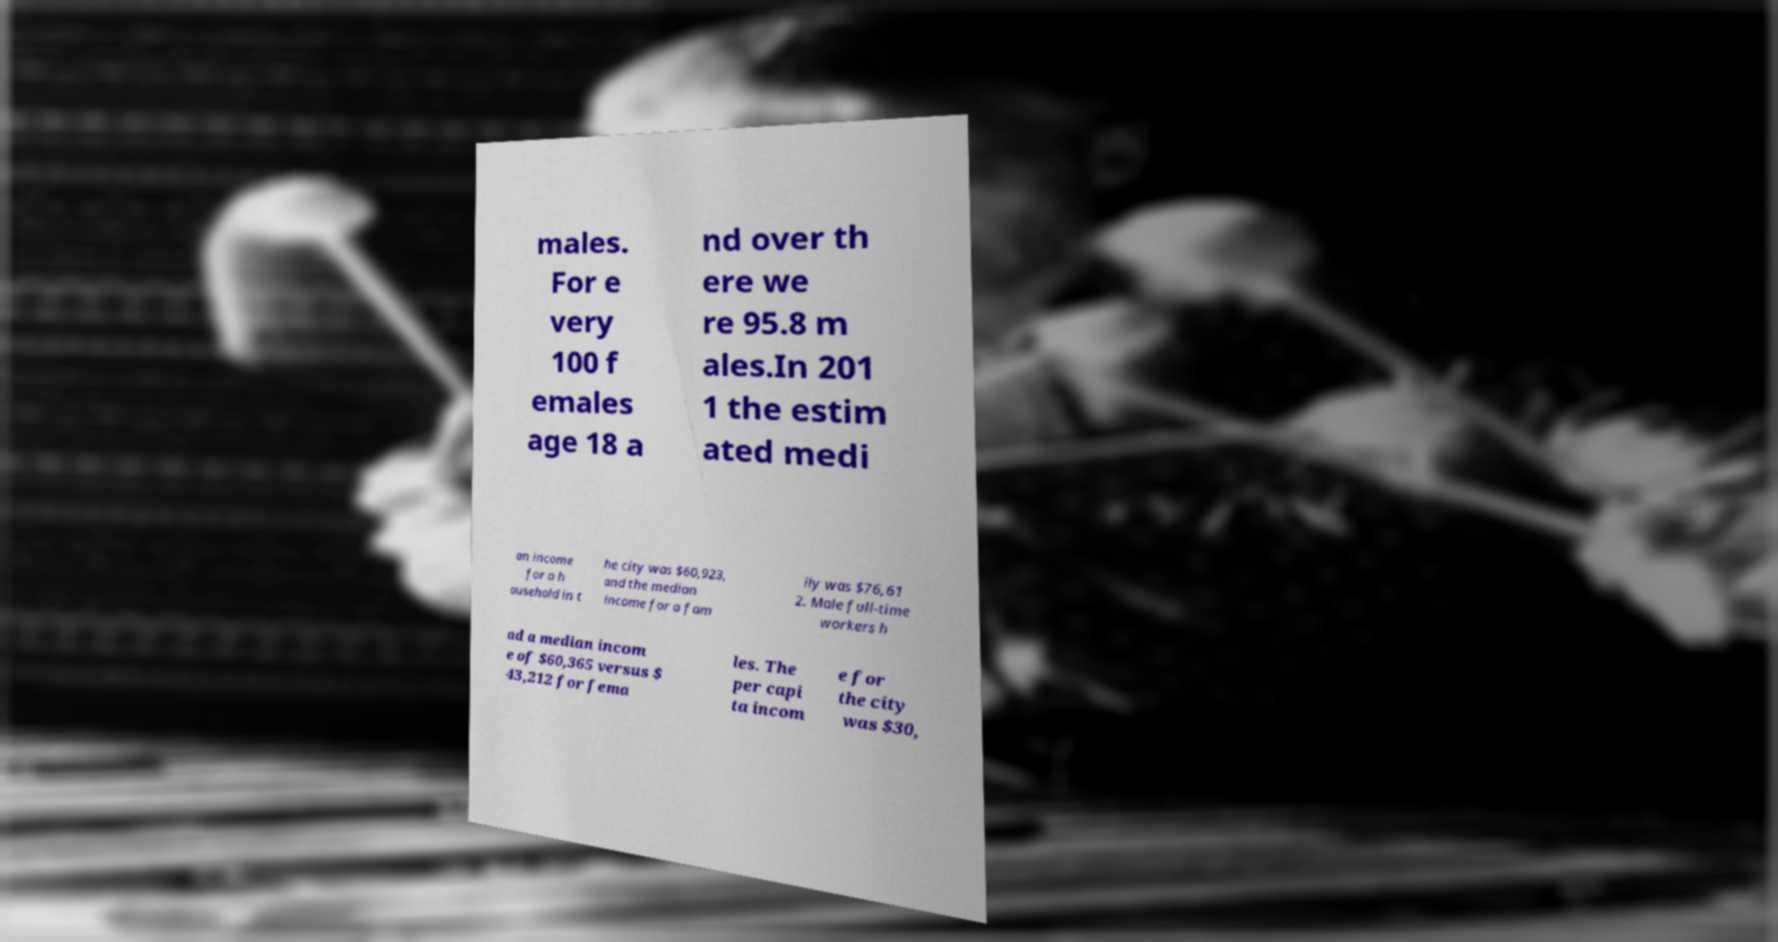Can you accurately transcribe the text from the provided image for me? males. For e very 100 f emales age 18 a nd over th ere we re 95.8 m ales.In 201 1 the estim ated medi an income for a h ousehold in t he city was $60,923, and the median income for a fam ily was $76,61 2. Male full-time workers h ad a median incom e of $60,365 versus $ 43,212 for fema les. The per capi ta incom e for the city was $30, 